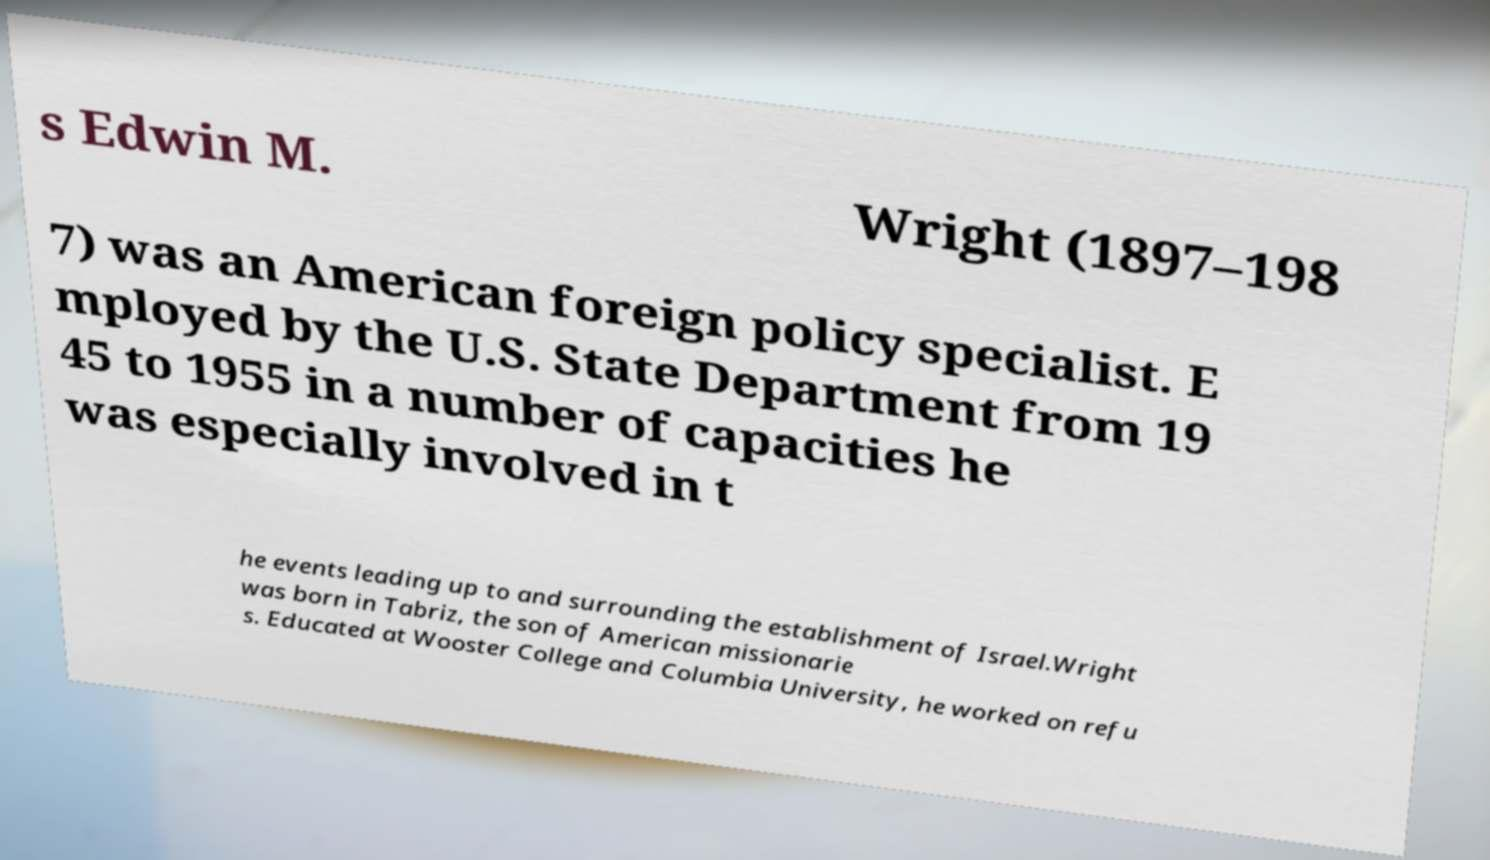For documentation purposes, I need the text within this image transcribed. Could you provide that? s Edwin M. Wright (1897–198 7) was an American foreign policy specialist. E mployed by the U.S. State Department from 19 45 to 1955 in a number of capacities he was especially involved in t he events leading up to and surrounding the establishment of Israel.Wright was born in Tabriz, the son of American missionarie s. Educated at Wooster College and Columbia University, he worked on refu 